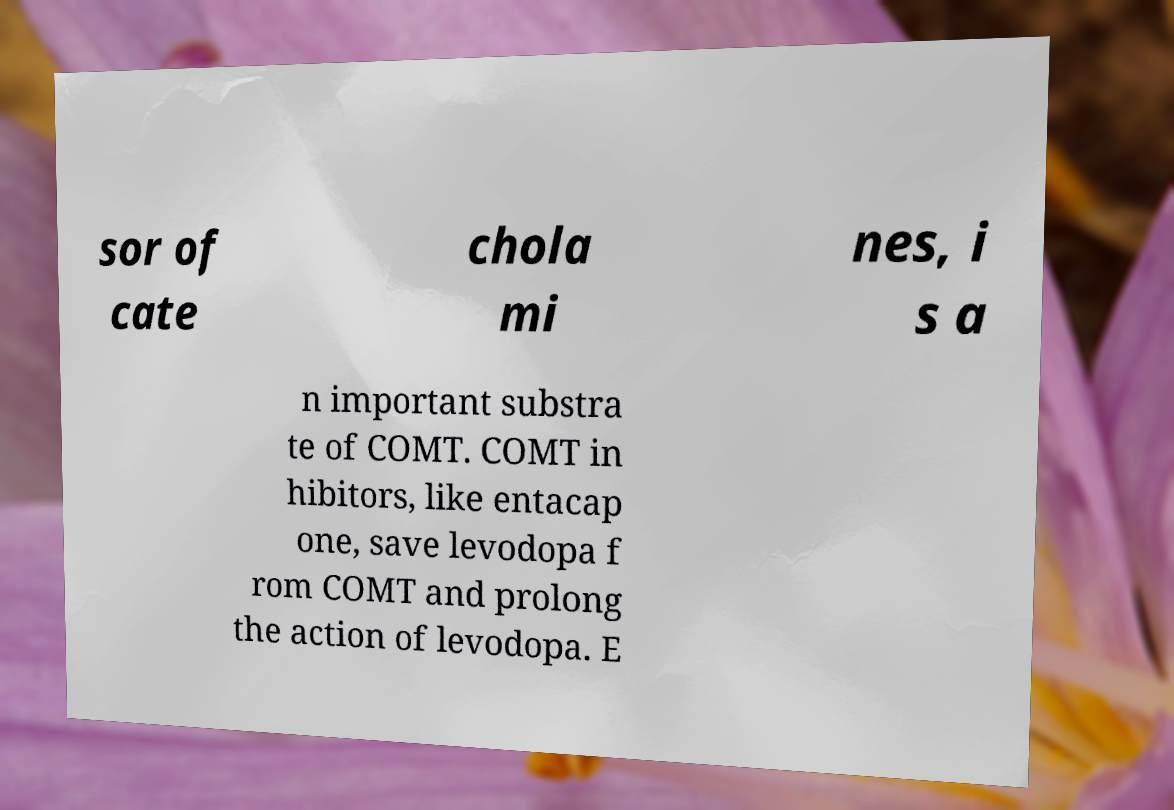Please identify and transcribe the text found in this image. sor of cate chola mi nes, i s a n important substra te of COMT. COMT in hibitors, like entacap one, save levodopa f rom COMT and prolong the action of levodopa. E 